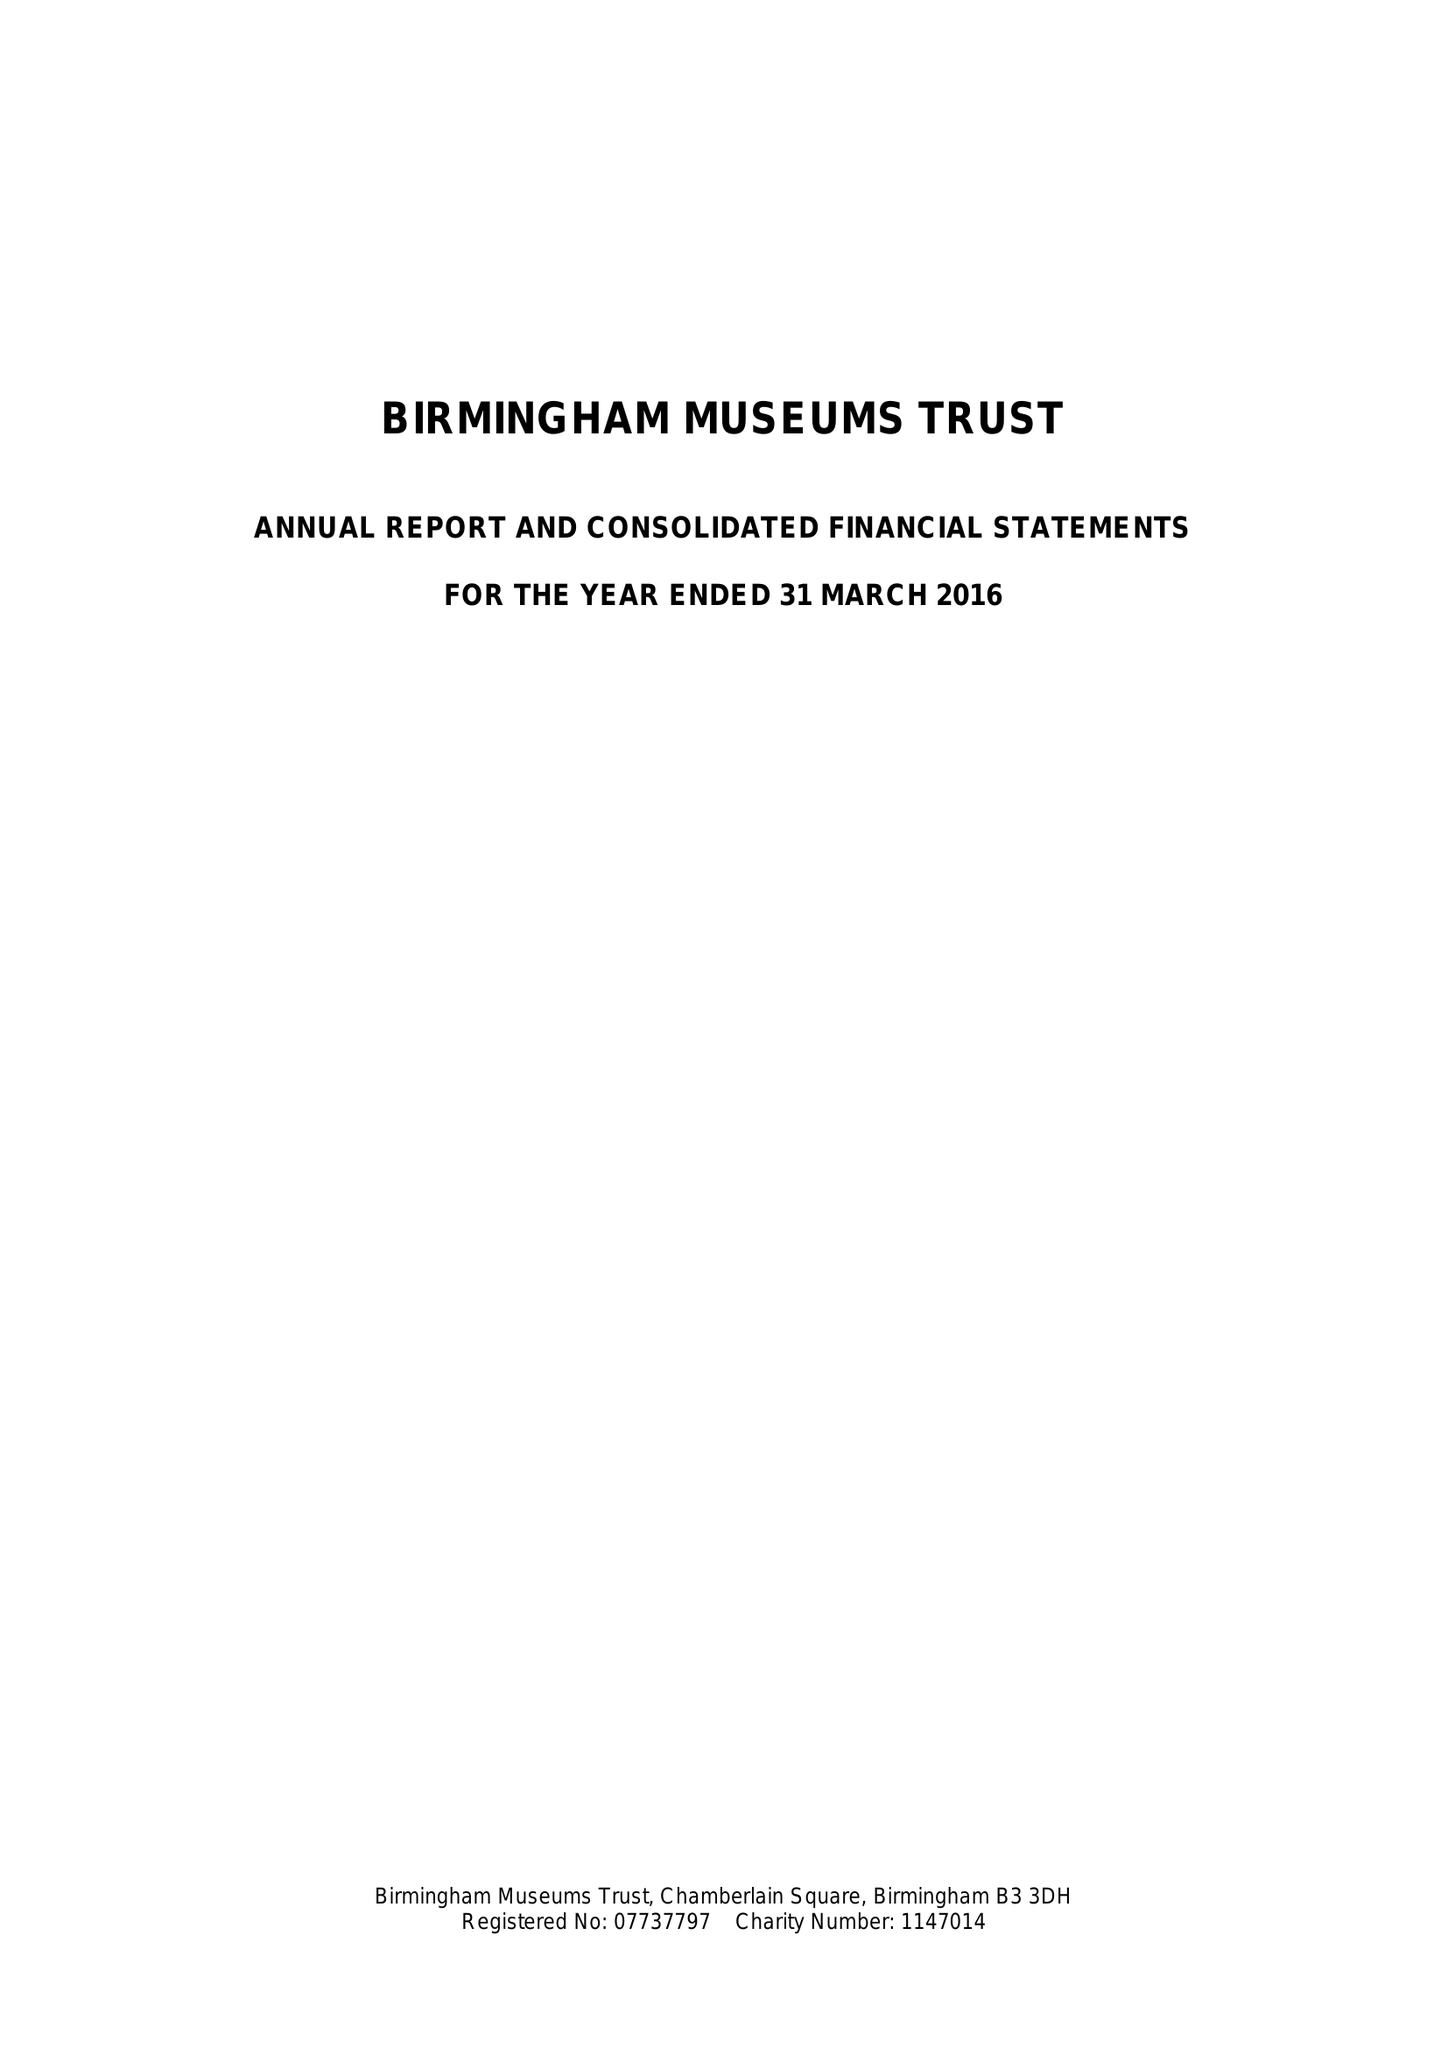What is the value for the address__postcode?
Answer the question using a single word or phrase. B3 3DH 